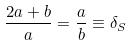Convert formula to latex. <formula><loc_0><loc_0><loc_500><loc_500>\frac { 2 a + b } { a } = \frac { a } { b } \equiv \delta _ { S }</formula> 